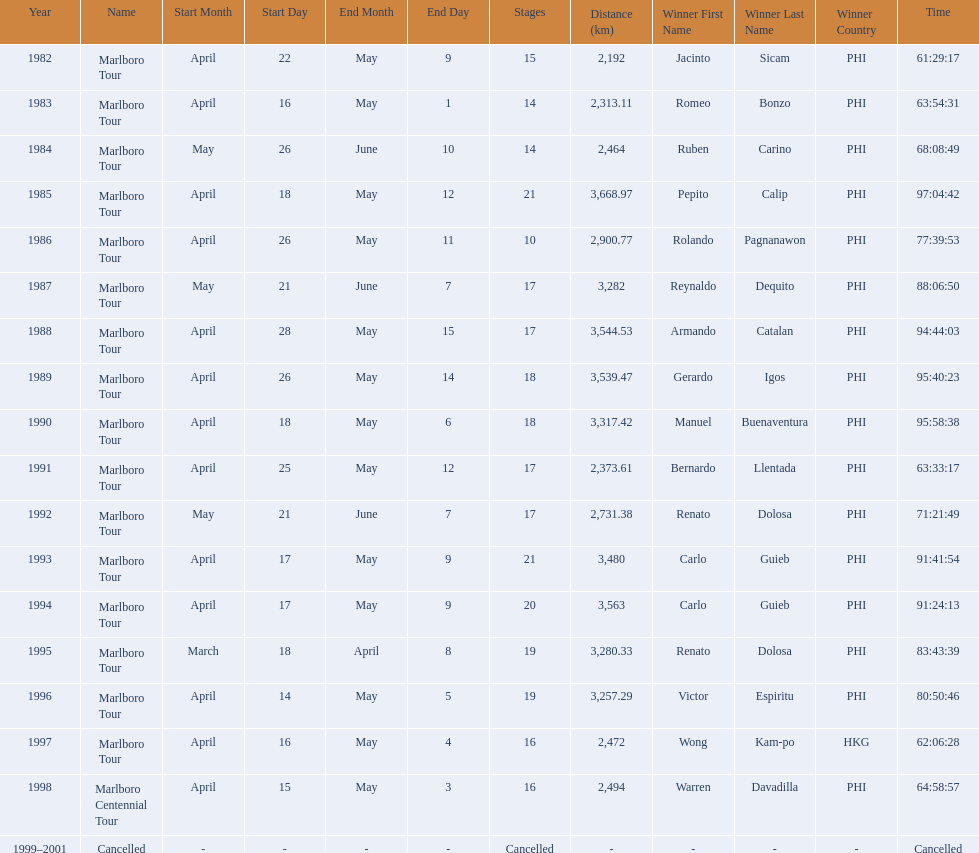What are the distances travelled on the tour? 2,192 km, 2,313.11 km, 2,464 km, 3,668.97 km, 2,900.77 km, 3,282 km, 3,544.53 km, 3,539.47 km, 3,317.42 km, 2,373.61 km, 2,731.38 km, 3,480 km, 3,563 km, 3,280.33 km, 3,257.29 km, 2,472 km, 2,494 km. Which of these are the largest? 3,668.97 km. Parse the table in full. {'header': ['Year', 'Name', 'Start Month', 'Start Day', 'End Month', 'End Day', 'Stages', 'Distance (km)', 'Winner First Name', 'Winner Last Name', 'Winner Country', 'Time'], 'rows': [['1982', 'Marlboro Tour', 'April', '22', 'May', '9', '15', '2,192', 'Jacinto', 'Sicam', 'PHI', '61:29:17'], ['1983', 'Marlboro Tour', 'April', '16', 'May', '1', '14', '2,313.11', 'Romeo', 'Bonzo', 'PHI', '63:54:31'], ['1984', 'Marlboro Tour', 'May', '26', 'June', '10', '14', '2,464', 'Ruben', 'Carino', 'PHI', '68:08:49'], ['1985', 'Marlboro Tour', 'April', '18', 'May', '12', '21', '3,668.97', 'Pepito', 'Calip', 'PHI', '97:04:42'], ['1986', 'Marlboro Tour', 'April', '26', 'May', '11', '10', '2,900.77', 'Rolando', 'Pagnanawon', 'PHI', '77:39:53'], ['1987', 'Marlboro Tour', 'May', '21', 'June', '7', '17', '3,282', 'Reynaldo', 'Dequito', 'PHI', '88:06:50'], ['1988', 'Marlboro Tour', 'April', '28', 'May', '15', '17', '3,544.53', 'Armando', 'Catalan', 'PHI', '94:44:03'], ['1989', 'Marlboro Tour', 'April', '26', 'May', '14', '18', '3,539.47', 'Gerardo', 'Igos', 'PHI', '95:40:23'], ['1990', 'Marlboro Tour', 'April', '18', 'May', '6', '18', '3,317.42', 'Manuel', 'Buenaventura', 'PHI', '95:58:38'], ['1991', 'Marlboro Tour', 'April', '25', 'May', '12', '17', '2,373.61', 'Bernardo', 'Llentada', 'PHI', '63:33:17'], ['1992', 'Marlboro Tour', 'May', '21', 'June', '7', '17', '2,731.38', 'Renato', 'Dolosa', 'PHI', '71:21:49'], ['1993', 'Marlboro Tour', 'April', '17', 'May', '9', '21', '3,480', 'Carlo', 'Guieb', 'PHI', '91:41:54'], ['1994', 'Marlboro Tour', 'April', '17', 'May', '9', '20', '3,563', 'Carlo', 'Guieb', 'PHI', '91:24:13'], ['1995', 'Marlboro Tour', 'March', '18', 'April', '8', '19', '3,280.33', 'Renato', 'Dolosa', 'PHI', '83:43:39'], ['1996', 'Marlboro Tour', 'April', '14', 'May', '5', '19', '3,257.29', 'Victor', 'Espiritu', 'PHI', '80:50:46'], ['1997', 'Marlboro Tour', 'April', '16', 'May', '4', '16', '2,472', 'Wong', 'Kam-po', 'HKG', '62:06:28'], ['1998', 'Marlboro Centennial Tour', 'April', '15', 'May', '3', '16', '2,494', 'Warren', 'Davadilla', 'PHI', '64:58:57'], ['1999–2001', 'Cancelled', '-', '-', '-', '-', 'Cancelled', '-', '-', '-', '-', 'Cancelled']]} 